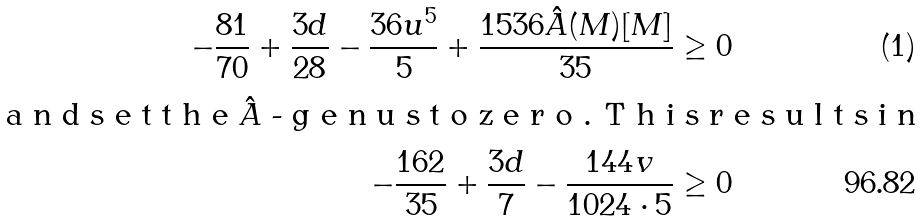<formula> <loc_0><loc_0><loc_500><loc_500>- \frac { 8 1 } { 7 0 } + \frac { 3 d } { 2 8 } - \frac { 3 6 u ^ { 5 } } { 5 } + \frac { 1 5 3 6 \hat { A } ( M ) [ M ] } { 3 5 } \geq 0 \intertext { a n d s e t t h e $ \hat { A } $ - g e n u s t o z e r o . T h i s r e s u l t s i n } - \frac { 1 6 2 } { 3 5 } + \frac { 3 d } { 7 } - \frac { 1 4 4 v } { 1 0 2 4 \cdot 5 } \geq 0</formula> 